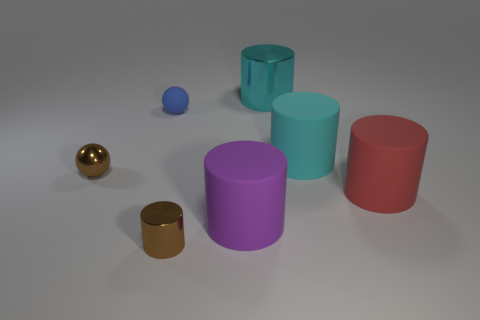Are there any rubber cylinders that have the same color as the big shiny object?
Your response must be concise. Yes. There is another big cylinder that is the same color as the big shiny cylinder; what is it made of?
Offer a terse response. Rubber. What shape is the big purple rubber object?
Give a very brief answer. Cylinder. How many things are either cyan cylinders right of the big cyan metal cylinder or cyan balls?
Offer a terse response. 1. What number of other things are there of the same color as the small shiny sphere?
Provide a short and direct response. 1. There is a large shiny object; does it have the same color as the large rubber cylinder behind the brown metal ball?
Provide a short and direct response. Yes. There is another metal object that is the same shape as the big metallic thing; what is its color?
Your answer should be very brief. Brown. Are the brown cylinder and the cyan cylinder that is in front of the tiny blue ball made of the same material?
Provide a succinct answer. No. What color is the small cylinder?
Provide a short and direct response. Brown. There is a rubber thing to the left of the tiny brown object in front of the small shiny thing that is behind the purple matte cylinder; what color is it?
Ensure brevity in your answer.  Blue. 